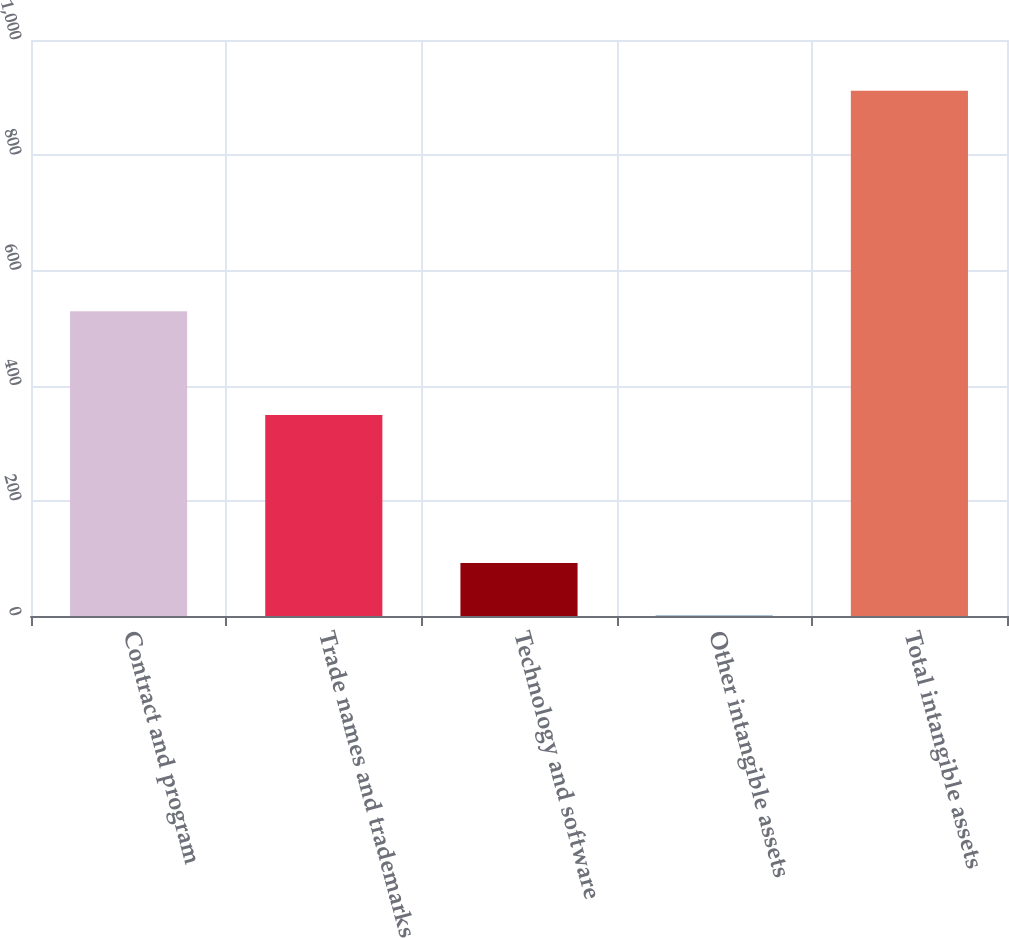<chart> <loc_0><loc_0><loc_500><loc_500><bar_chart><fcel>Contract and program<fcel>Trade names and trademarks<fcel>Technology and software<fcel>Other intangible assets<fcel>Total intangible assets<nl><fcel>529<fcel>349<fcel>92.1<fcel>1<fcel>912<nl></chart> 